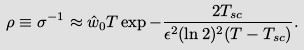Convert formula to latex. <formula><loc_0><loc_0><loc_500><loc_500>\rho \equiv \sigma ^ { - 1 } \approx \hat { w } _ { 0 } T \exp { - \frac { 2 T _ { s c } } { \epsilon ^ { 2 } ( \ln 2 ) ^ { 2 } ( T - T _ { s c } ) } } .</formula> 